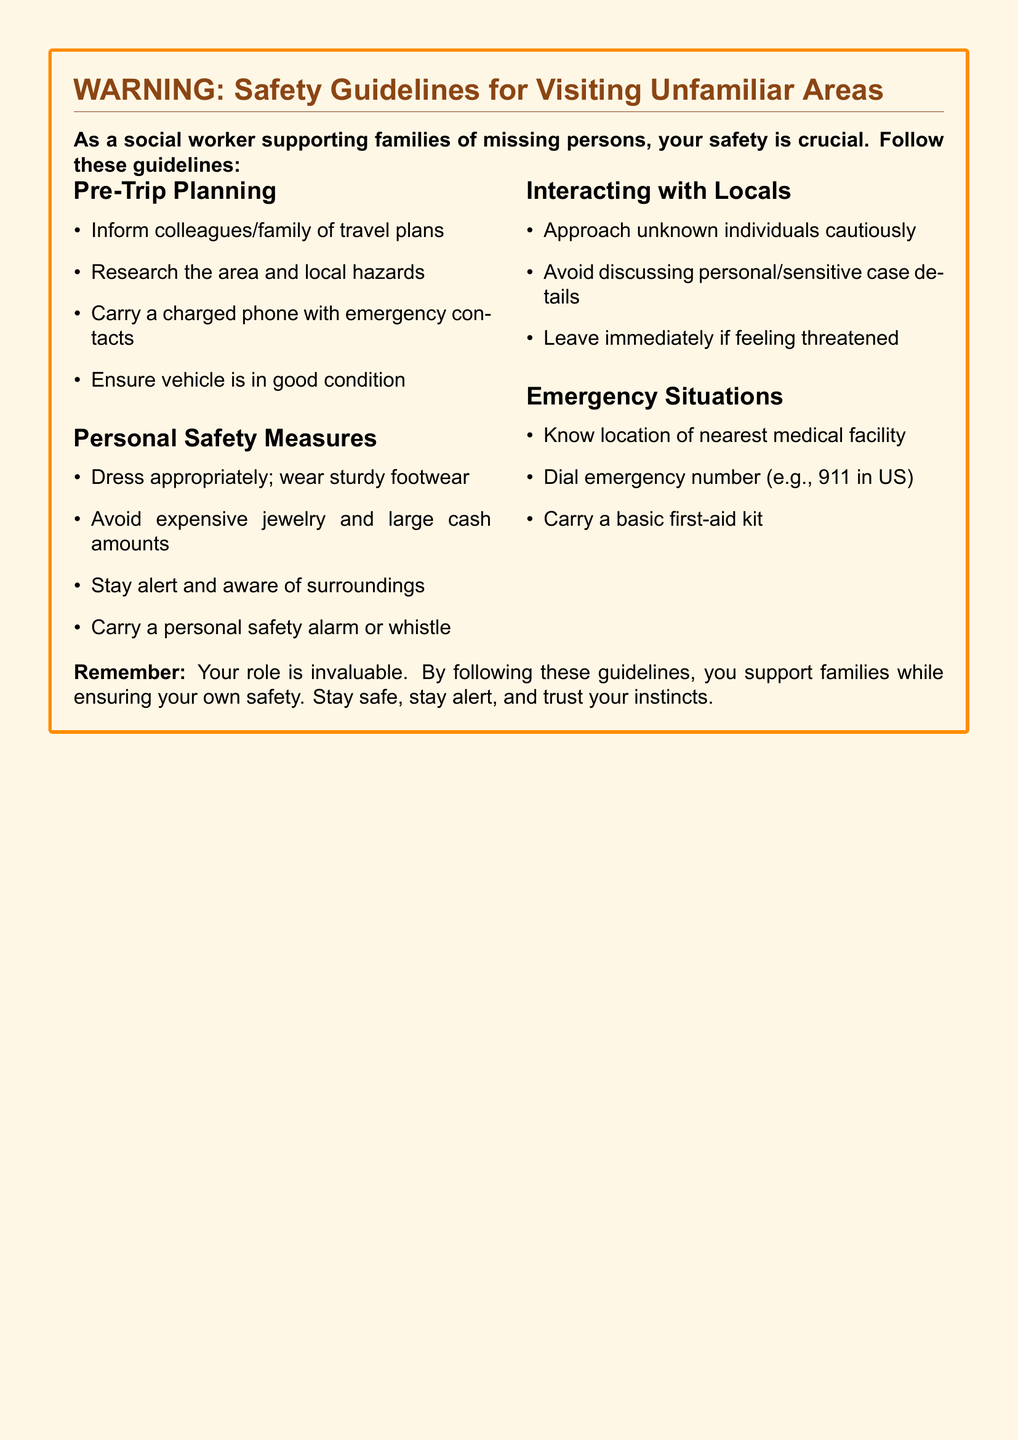What is the primary focus of this warning document? The document emphasizes the safety guidelines for individuals helping to search for missing persons in unfamiliar areas.
Answer: Safety guidelines for visiting unfamiliar areas How many sections are in the document? There are four main sections listed: Pre-Trip Planning, Personal Safety Measures, Interacting with Locals, and Emergency Situations.
Answer: Four What should you carry with you according to the Pre-Trip Planning section? The Pre-Trip Planning section advises carrying a charged phone with emergency contacts.
Answer: Charged phone with emergency contacts What is the first item listed under Personal Safety Measures? The first item recommended is to dress appropriately, focusing on wearing sturdy footwear for safety.
Answer: Dress appropriately; wear sturdy footwear What should you do if you feel threatened according to the Interacting with Locals section? The document advises leaving immediately if feeling threatened.
Answer: Leave immediately if feeling threatened What emergency number is mentioned in the Emergency Situations section? The document specifies dialing 911 as the emergency number in the US.
Answer: 911 Why is it important to inform colleagues or family of travel plans? Informing others of your travel plans ensures someone is aware of your whereabouts for safety reasons.
Answer: Safety reasons What type of kit should be carried according to the Emergency Situations section? A basic first-aid kit is recommended to be carried for emergency preparedness.
Answer: Basic first-aid kit 